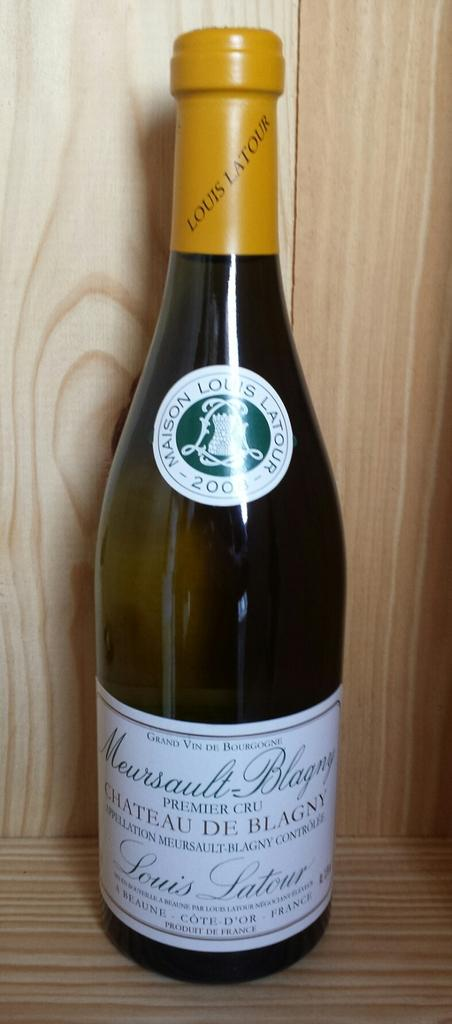Provide a one-sentence caption for the provided image. A bottle of Louis Latour wine sits on a wood surface. 